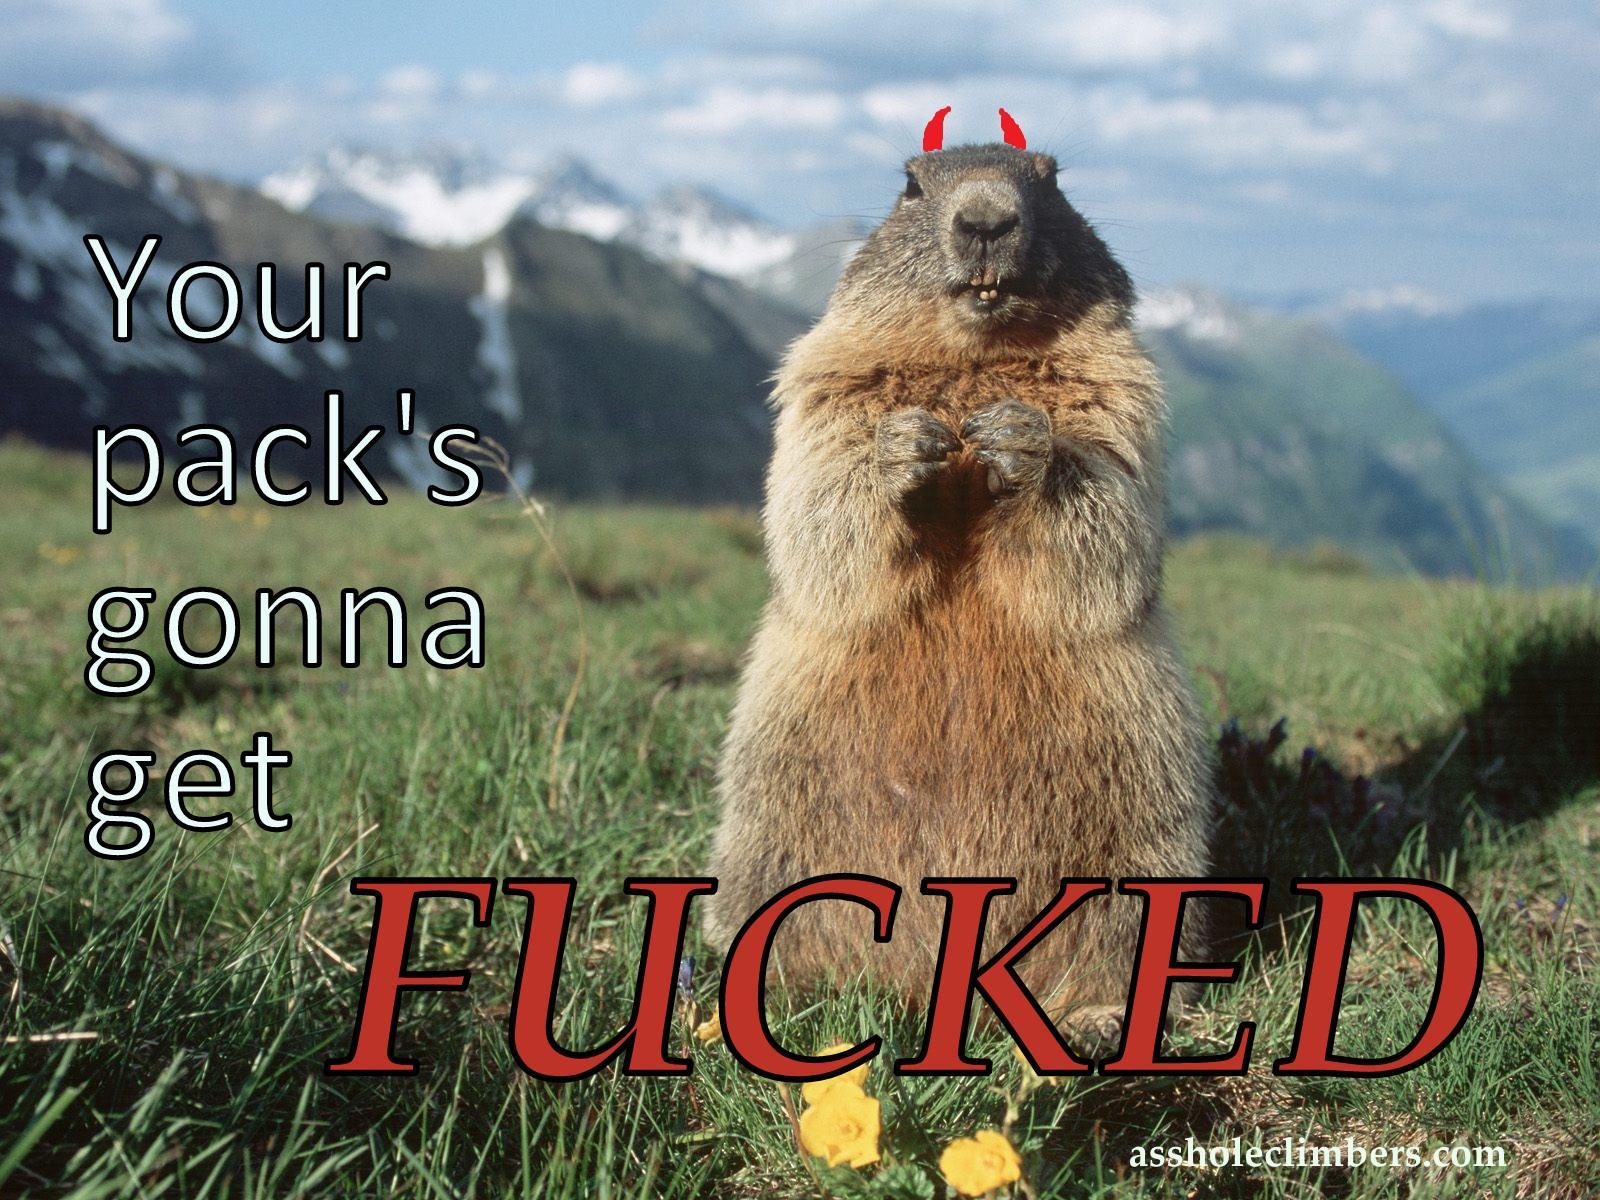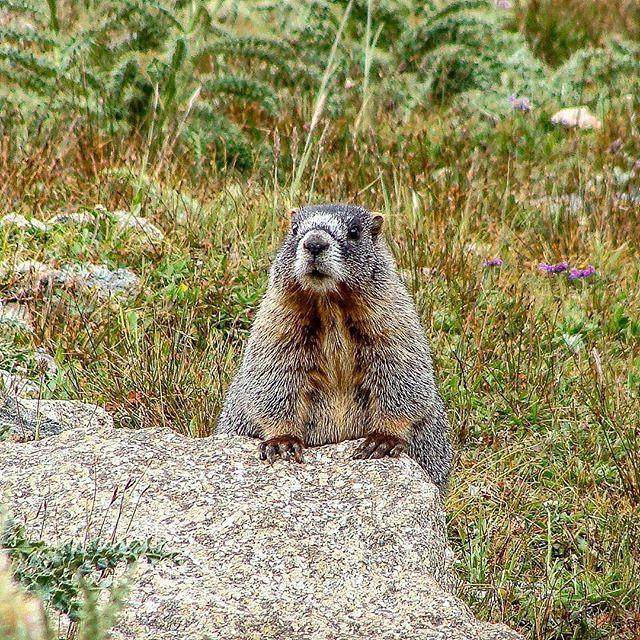The first image is the image on the left, the second image is the image on the right. For the images displayed, is the sentence "There is exactly two rodents." factually correct? Answer yes or no. Yes. 